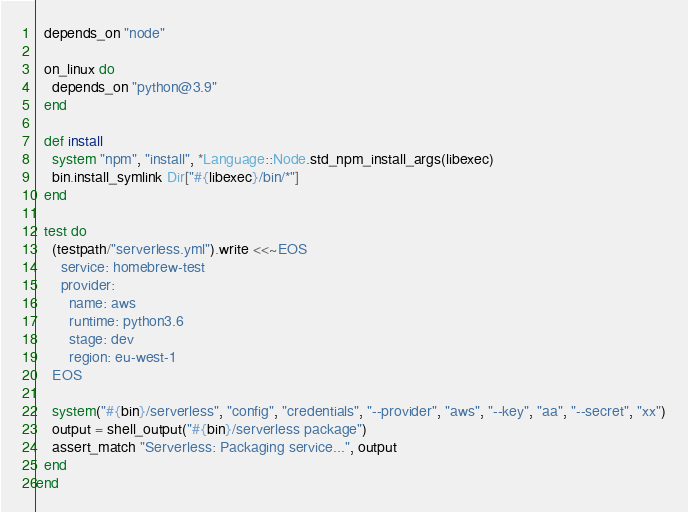Convert code to text. <code><loc_0><loc_0><loc_500><loc_500><_Ruby_>
  depends_on "node"

  on_linux do
    depends_on "python@3.9"
  end

  def install
    system "npm", "install", *Language::Node.std_npm_install_args(libexec)
    bin.install_symlink Dir["#{libexec}/bin/*"]
  end

  test do
    (testpath/"serverless.yml").write <<~EOS
      service: homebrew-test
      provider:
        name: aws
        runtime: python3.6
        stage: dev
        region: eu-west-1
    EOS

    system("#{bin}/serverless", "config", "credentials", "--provider", "aws", "--key", "aa", "--secret", "xx")
    output = shell_output("#{bin}/serverless package")
    assert_match "Serverless: Packaging service...", output
  end
end
</code> 